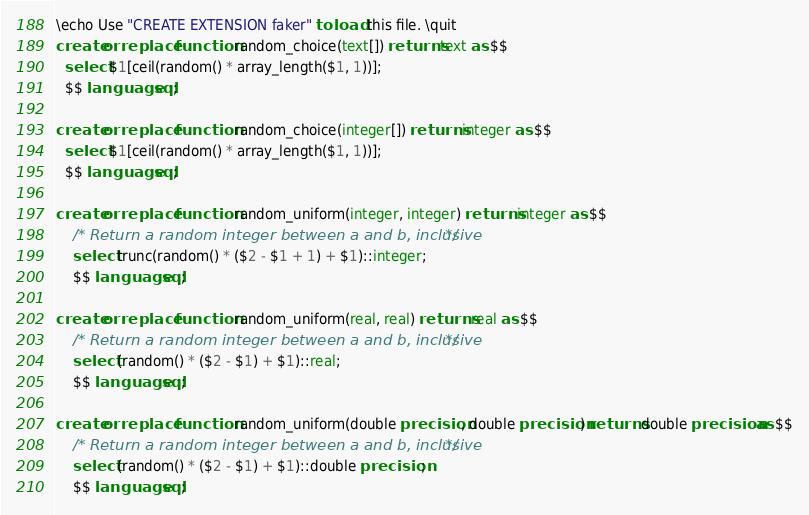<code> <loc_0><loc_0><loc_500><loc_500><_SQL_>\echo Use "CREATE EXTENSION faker" to load this file. \quit
create or replace function random_choice(text[]) returns text as $$
  select $1[ceil(random() * array_length($1, 1))];
  $$ language sql;

create or replace function random_choice(integer[]) returns integer as $$
  select $1[ceil(random() * array_length($1, 1))];
  $$ language sql;

create or replace function random_uniform(integer, integer) returns integer as $$
	/* Return a random integer between a and b, inclusive */
	select trunc(random() * ($2 - $1 + 1) + $1)::integer;
	$$ language sql;

create or replace function random_uniform(real, real) returns real as $$
	/* Return a random integer between a and b, inclusive */
	select (random() * ($2 - $1) + $1)::real;
	$$ language sql;

create or replace function random_uniform(double precision, double precision) returns double precision as $$
	/* Return a random integer between a and b, inclusive */
	select (random() * ($2 - $1) + $1)::double precision;
	$$ language sql;
</code> 